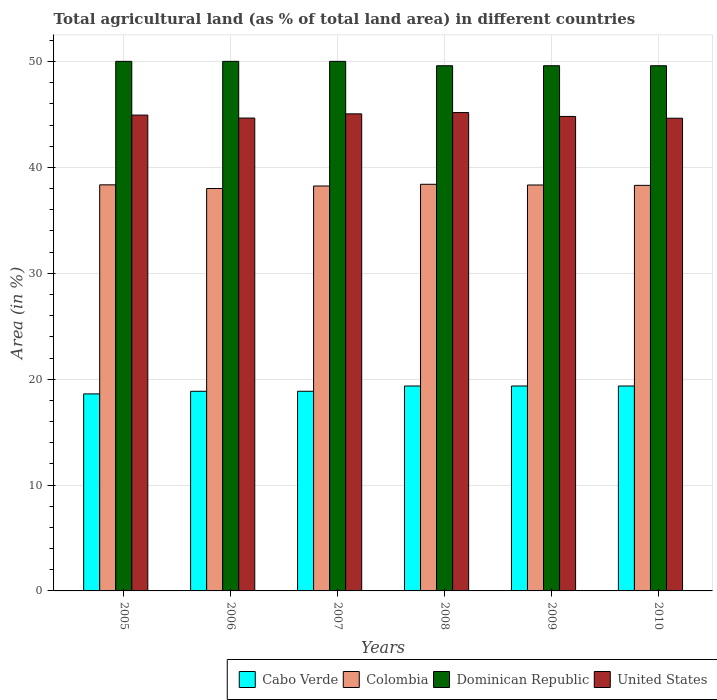Are the number of bars on each tick of the X-axis equal?
Give a very brief answer. Yes. How many bars are there on the 2nd tick from the left?
Offer a terse response. 4. What is the label of the 6th group of bars from the left?
Provide a short and direct response. 2010. In how many cases, is the number of bars for a given year not equal to the number of legend labels?
Offer a terse response. 0. What is the percentage of agricultural land in Colombia in 2007?
Your answer should be very brief. 38.25. Across all years, what is the maximum percentage of agricultural land in Dominican Republic?
Make the answer very short. 50.02. Across all years, what is the minimum percentage of agricultural land in Cabo Verde?
Keep it short and to the point. 18.61. In which year was the percentage of agricultural land in Dominican Republic minimum?
Provide a short and direct response. 2008. What is the total percentage of agricultural land in Colombia in the graph?
Ensure brevity in your answer.  229.67. What is the difference between the percentage of agricultural land in Cabo Verde in 2009 and the percentage of agricultural land in United States in 2006?
Your answer should be compact. -25.31. What is the average percentage of agricultural land in Cabo Verde per year?
Ensure brevity in your answer.  19.07. In the year 2006, what is the difference between the percentage of agricultural land in Colombia and percentage of agricultural land in Cabo Verde?
Your answer should be very brief. 19.15. What is the ratio of the percentage of agricultural land in United States in 2006 to that in 2010?
Ensure brevity in your answer.  1. Is the percentage of agricultural land in Dominican Republic in 2006 less than that in 2009?
Your response must be concise. No. What is the difference between the highest and the second highest percentage of agricultural land in Colombia?
Provide a short and direct response. 0.05. What is the difference between the highest and the lowest percentage of agricultural land in United States?
Offer a very short reply. 0.53. In how many years, is the percentage of agricultural land in Colombia greater than the average percentage of agricultural land in Colombia taken over all years?
Ensure brevity in your answer.  4. Is the sum of the percentage of agricultural land in Colombia in 2006 and 2007 greater than the maximum percentage of agricultural land in Dominican Republic across all years?
Offer a terse response. Yes. Is it the case that in every year, the sum of the percentage of agricultural land in Dominican Republic and percentage of agricultural land in United States is greater than the sum of percentage of agricultural land in Cabo Verde and percentage of agricultural land in Colombia?
Offer a very short reply. Yes. What does the 3rd bar from the left in 2005 represents?
Your answer should be compact. Dominican Republic. What does the 4th bar from the right in 2007 represents?
Your answer should be compact. Cabo Verde. How many bars are there?
Your answer should be compact. 24. What is the difference between two consecutive major ticks on the Y-axis?
Provide a succinct answer. 10. Are the values on the major ticks of Y-axis written in scientific E-notation?
Ensure brevity in your answer.  No. Does the graph contain grids?
Provide a succinct answer. Yes. Where does the legend appear in the graph?
Provide a short and direct response. Bottom right. How many legend labels are there?
Your answer should be compact. 4. What is the title of the graph?
Offer a terse response. Total agricultural land (as % of total land area) in different countries. What is the label or title of the X-axis?
Give a very brief answer. Years. What is the label or title of the Y-axis?
Offer a terse response. Area (in %). What is the Area (in %) in Cabo Verde in 2005?
Keep it short and to the point. 18.61. What is the Area (in %) in Colombia in 2005?
Provide a short and direct response. 38.36. What is the Area (in %) of Dominican Republic in 2005?
Offer a terse response. 50.02. What is the Area (in %) of United States in 2005?
Your answer should be very brief. 44.95. What is the Area (in %) in Cabo Verde in 2006?
Your response must be concise. 18.86. What is the Area (in %) in Colombia in 2006?
Offer a terse response. 38.01. What is the Area (in %) in Dominican Republic in 2006?
Offer a terse response. 50.02. What is the Area (in %) of United States in 2006?
Give a very brief answer. 44.66. What is the Area (in %) in Cabo Verde in 2007?
Your answer should be very brief. 18.86. What is the Area (in %) in Colombia in 2007?
Give a very brief answer. 38.25. What is the Area (in %) of Dominican Republic in 2007?
Your answer should be very brief. 50.02. What is the Area (in %) of United States in 2007?
Provide a short and direct response. 45.06. What is the Area (in %) of Cabo Verde in 2008?
Offer a terse response. 19.35. What is the Area (in %) of Colombia in 2008?
Your answer should be compact. 38.41. What is the Area (in %) in Dominican Republic in 2008?
Your answer should be compact. 49.61. What is the Area (in %) in United States in 2008?
Give a very brief answer. 45.18. What is the Area (in %) in Cabo Verde in 2009?
Provide a short and direct response. 19.35. What is the Area (in %) of Colombia in 2009?
Your answer should be compact. 38.34. What is the Area (in %) of Dominican Republic in 2009?
Your answer should be very brief. 49.61. What is the Area (in %) in United States in 2009?
Your response must be concise. 44.82. What is the Area (in %) in Cabo Verde in 2010?
Provide a succinct answer. 19.35. What is the Area (in %) of Colombia in 2010?
Provide a short and direct response. 38.31. What is the Area (in %) in Dominican Republic in 2010?
Make the answer very short. 49.61. What is the Area (in %) of United States in 2010?
Provide a succinct answer. 44.65. Across all years, what is the maximum Area (in %) in Cabo Verde?
Offer a terse response. 19.35. Across all years, what is the maximum Area (in %) in Colombia?
Keep it short and to the point. 38.41. Across all years, what is the maximum Area (in %) of Dominican Republic?
Your response must be concise. 50.02. Across all years, what is the maximum Area (in %) of United States?
Provide a succinct answer. 45.18. Across all years, what is the minimum Area (in %) in Cabo Verde?
Ensure brevity in your answer.  18.61. Across all years, what is the minimum Area (in %) in Colombia?
Your answer should be very brief. 38.01. Across all years, what is the minimum Area (in %) in Dominican Republic?
Provide a succinct answer. 49.61. Across all years, what is the minimum Area (in %) in United States?
Provide a short and direct response. 44.65. What is the total Area (in %) of Cabo Verde in the graph?
Your answer should be compact. 114.39. What is the total Area (in %) in Colombia in the graph?
Offer a terse response. 229.67. What is the total Area (in %) in Dominican Republic in the graph?
Provide a short and direct response. 298.88. What is the total Area (in %) of United States in the graph?
Offer a terse response. 269.32. What is the difference between the Area (in %) of Cabo Verde in 2005 and that in 2006?
Provide a succinct answer. -0.25. What is the difference between the Area (in %) in Colombia in 2005 and that in 2006?
Give a very brief answer. 0.35. What is the difference between the Area (in %) of Dominican Republic in 2005 and that in 2006?
Offer a very short reply. 0. What is the difference between the Area (in %) of United States in 2005 and that in 2006?
Make the answer very short. 0.28. What is the difference between the Area (in %) in Cabo Verde in 2005 and that in 2007?
Give a very brief answer. -0.25. What is the difference between the Area (in %) of Colombia in 2005 and that in 2007?
Make the answer very short. 0.11. What is the difference between the Area (in %) of Dominican Republic in 2005 and that in 2007?
Keep it short and to the point. 0. What is the difference between the Area (in %) of United States in 2005 and that in 2007?
Offer a very short reply. -0.12. What is the difference between the Area (in %) in Cabo Verde in 2005 and that in 2008?
Ensure brevity in your answer.  -0.74. What is the difference between the Area (in %) in Colombia in 2005 and that in 2008?
Your answer should be compact. -0.05. What is the difference between the Area (in %) of Dominican Republic in 2005 and that in 2008?
Your answer should be compact. 0.41. What is the difference between the Area (in %) in United States in 2005 and that in 2008?
Your answer should be very brief. -0.24. What is the difference between the Area (in %) in Cabo Verde in 2005 and that in 2009?
Give a very brief answer. -0.74. What is the difference between the Area (in %) in Colombia in 2005 and that in 2009?
Ensure brevity in your answer.  0.02. What is the difference between the Area (in %) in Dominican Republic in 2005 and that in 2009?
Provide a short and direct response. 0.41. What is the difference between the Area (in %) in United States in 2005 and that in 2009?
Give a very brief answer. 0.13. What is the difference between the Area (in %) of Cabo Verde in 2005 and that in 2010?
Your response must be concise. -0.74. What is the difference between the Area (in %) in Colombia in 2005 and that in 2010?
Give a very brief answer. 0.05. What is the difference between the Area (in %) in Dominican Republic in 2005 and that in 2010?
Provide a short and direct response. 0.41. What is the difference between the Area (in %) of United States in 2005 and that in 2010?
Your answer should be compact. 0.3. What is the difference between the Area (in %) in Cabo Verde in 2006 and that in 2007?
Your answer should be compact. 0. What is the difference between the Area (in %) in Colombia in 2006 and that in 2007?
Keep it short and to the point. -0.24. What is the difference between the Area (in %) of Dominican Republic in 2006 and that in 2007?
Ensure brevity in your answer.  0. What is the difference between the Area (in %) of United States in 2006 and that in 2007?
Offer a terse response. -0.4. What is the difference between the Area (in %) of Cabo Verde in 2006 and that in 2008?
Ensure brevity in your answer.  -0.5. What is the difference between the Area (in %) in Colombia in 2006 and that in 2008?
Offer a very short reply. -0.4. What is the difference between the Area (in %) in Dominican Republic in 2006 and that in 2008?
Your answer should be compact. 0.41. What is the difference between the Area (in %) in United States in 2006 and that in 2008?
Your response must be concise. -0.52. What is the difference between the Area (in %) of Cabo Verde in 2006 and that in 2009?
Keep it short and to the point. -0.5. What is the difference between the Area (in %) in Colombia in 2006 and that in 2009?
Your response must be concise. -0.33. What is the difference between the Area (in %) in Dominican Republic in 2006 and that in 2009?
Provide a succinct answer. 0.41. What is the difference between the Area (in %) in United States in 2006 and that in 2009?
Keep it short and to the point. -0.15. What is the difference between the Area (in %) in Cabo Verde in 2006 and that in 2010?
Your answer should be compact. -0.5. What is the difference between the Area (in %) in Colombia in 2006 and that in 2010?
Give a very brief answer. -0.3. What is the difference between the Area (in %) of Dominican Republic in 2006 and that in 2010?
Offer a terse response. 0.41. What is the difference between the Area (in %) in United States in 2006 and that in 2010?
Your answer should be compact. 0.02. What is the difference between the Area (in %) in Cabo Verde in 2007 and that in 2008?
Your answer should be very brief. -0.5. What is the difference between the Area (in %) of Colombia in 2007 and that in 2008?
Provide a succinct answer. -0.16. What is the difference between the Area (in %) in Dominican Republic in 2007 and that in 2008?
Offer a very short reply. 0.41. What is the difference between the Area (in %) in United States in 2007 and that in 2008?
Offer a very short reply. -0.12. What is the difference between the Area (in %) of Cabo Verde in 2007 and that in 2009?
Keep it short and to the point. -0.5. What is the difference between the Area (in %) in Colombia in 2007 and that in 2009?
Provide a succinct answer. -0.09. What is the difference between the Area (in %) of Dominican Republic in 2007 and that in 2009?
Provide a short and direct response. 0.41. What is the difference between the Area (in %) of United States in 2007 and that in 2009?
Your answer should be compact. 0.25. What is the difference between the Area (in %) in Cabo Verde in 2007 and that in 2010?
Your answer should be very brief. -0.5. What is the difference between the Area (in %) in Colombia in 2007 and that in 2010?
Offer a very short reply. -0.06. What is the difference between the Area (in %) of Dominican Republic in 2007 and that in 2010?
Ensure brevity in your answer.  0.41. What is the difference between the Area (in %) of United States in 2007 and that in 2010?
Make the answer very short. 0.41. What is the difference between the Area (in %) of Colombia in 2008 and that in 2009?
Your answer should be compact. 0.07. What is the difference between the Area (in %) in United States in 2008 and that in 2009?
Provide a succinct answer. 0.37. What is the difference between the Area (in %) in Dominican Republic in 2008 and that in 2010?
Give a very brief answer. 0. What is the difference between the Area (in %) in United States in 2008 and that in 2010?
Ensure brevity in your answer.  0.53. What is the difference between the Area (in %) in Cabo Verde in 2009 and that in 2010?
Your answer should be compact. 0. What is the difference between the Area (in %) of Dominican Republic in 2009 and that in 2010?
Your response must be concise. 0. What is the difference between the Area (in %) of United States in 2009 and that in 2010?
Ensure brevity in your answer.  0.17. What is the difference between the Area (in %) of Cabo Verde in 2005 and the Area (in %) of Colombia in 2006?
Ensure brevity in your answer.  -19.4. What is the difference between the Area (in %) of Cabo Verde in 2005 and the Area (in %) of Dominican Republic in 2006?
Your response must be concise. -31.41. What is the difference between the Area (in %) of Cabo Verde in 2005 and the Area (in %) of United States in 2006?
Keep it short and to the point. -26.05. What is the difference between the Area (in %) in Colombia in 2005 and the Area (in %) in Dominican Republic in 2006?
Offer a very short reply. -11.66. What is the difference between the Area (in %) of Colombia in 2005 and the Area (in %) of United States in 2006?
Your response must be concise. -6.31. What is the difference between the Area (in %) in Dominican Republic in 2005 and the Area (in %) in United States in 2006?
Give a very brief answer. 5.36. What is the difference between the Area (in %) of Cabo Verde in 2005 and the Area (in %) of Colombia in 2007?
Make the answer very short. -19.64. What is the difference between the Area (in %) in Cabo Verde in 2005 and the Area (in %) in Dominican Republic in 2007?
Provide a succinct answer. -31.41. What is the difference between the Area (in %) of Cabo Verde in 2005 and the Area (in %) of United States in 2007?
Make the answer very short. -26.45. What is the difference between the Area (in %) in Colombia in 2005 and the Area (in %) in Dominican Republic in 2007?
Ensure brevity in your answer.  -11.66. What is the difference between the Area (in %) in Colombia in 2005 and the Area (in %) in United States in 2007?
Offer a terse response. -6.71. What is the difference between the Area (in %) of Dominican Republic in 2005 and the Area (in %) of United States in 2007?
Keep it short and to the point. 4.96. What is the difference between the Area (in %) in Cabo Verde in 2005 and the Area (in %) in Colombia in 2008?
Provide a succinct answer. -19.8. What is the difference between the Area (in %) of Cabo Verde in 2005 and the Area (in %) of Dominican Republic in 2008?
Your answer should be compact. -31. What is the difference between the Area (in %) of Cabo Verde in 2005 and the Area (in %) of United States in 2008?
Give a very brief answer. -26.57. What is the difference between the Area (in %) of Colombia in 2005 and the Area (in %) of Dominican Republic in 2008?
Give a very brief answer. -11.25. What is the difference between the Area (in %) in Colombia in 2005 and the Area (in %) in United States in 2008?
Provide a succinct answer. -6.83. What is the difference between the Area (in %) in Dominican Republic in 2005 and the Area (in %) in United States in 2008?
Make the answer very short. 4.84. What is the difference between the Area (in %) of Cabo Verde in 2005 and the Area (in %) of Colombia in 2009?
Provide a succinct answer. -19.73. What is the difference between the Area (in %) in Cabo Verde in 2005 and the Area (in %) in Dominican Republic in 2009?
Ensure brevity in your answer.  -31. What is the difference between the Area (in %) in Cabo Verde in 2005 and the Area (in %) in United States in 2009?
Keep it short and to the point. -26.21. What is the difference between the Area (in %) of Colombia in 2005 and the Area (in %) of Dominican Republic in 2009?
Offer a very short reply. -11.25. What is the difference between the Area (in %) in Colombia in 2005 and the Area (in %) in United States in 2009?
Ensure brevity in your answer.  -6.46. What is the difference between the Area (in %) in Dominican Republic in 2005 and the Area (in %) in United States in 2009?
Ensure brevity in your answer.  5.2. What is the difference between the Area (in %) in Cabo Verde in 2005 and the Area (in %) in Colombia in 2010?
Offer a very short reply. -19.7. What is the difference between the Area (in %) of Cabo Verde in 2005 and the Area (in %) of Dominican Republic in 2010?
Ensure brevity in your answer.  -31. What is the difference between the Area (in %) of Cabo Verde in 2005 and the Area (in %) of United States in 2010?
Provide a succinct answer. -26.04. What is the difference between the Area (in %) in Colombia in 2005 and the Area (in %) in Dominican Republic in 2010?
Provide a short and direct response. -11.25. What is the difference between the Area (in %) in Colombia in 2005 and the Area (in %) in United States in 2010?
Provide a succinct answer. -6.29. What is the difference between the Area (in %) of Dominican Republic in 2005 and the Area (in %) of United States in 2010?
Provide a short and direct response. 5.37. What is the difference between the Area (in %) of Cabo Verde in 2006 and the Area (in %) of Colombia in 2007?
Ensure brevity in your answer.  -19.39. What is the difference between the Area (in %) in Cabo Verde in 2006 and the Area (in %) in Dominican Republic in 2007?
Offer a terse response. -31.16. What is the difference between the Area (in %) of Cabo Verde in 2006 and the Area (in %) of United States in 2007?
Offer a very short reply. -26.2. What is the difference between the Area (in %) in Colombia in 2006 and the Area (in %) in Dominican Republic in 2007?
Your answer should be very brief. -12.01. What is the difference between the Area (in %) of Colombia in 2006 and the Area (in %) of United States in 2007?
Provide a short and direct response. -7.05. What is the difference between the Area (in %) of Dominican Republic in 2006 and the Area (in %) of United States in 2007?
Your answer should be compact. 4.96. What is the difference between the Area (in %) in Cabo Verde in 2006 and the Area (in %) in Colombia in 2008?
Give a very brief answer. -19.55. What is the difference between the Area (in %) of Cabo Verde in 2006 and the Area (in %) of Dominican Republic in 2008?
Make the answer very short. -30.75. What is the difference between the Area (in %) of Cabo Verde in 2006 and the Area (in %) of United States in 2008?
Give a very brief answer. -26.32. What is the difference between the Area (in %) of Colombia in 2006 and the Area (in %) of Dominican Republic in 2008?
Ensure brevity in your answer.  -11.6. What is the difference between the Area (in %) of Colombia in 2006 and the Area (in %) of United States in 2008?
Offer a terse response. -7.17. What is the difference between the Area (in %) in Dominican Republic in 2006 and the Area (in %) in United States in 2008?
Your response must be concise. 4.84. What is the difference between the Area (in %) in Cabo Verde in 2006 and the Area (in %) in Colombia in 2009?
Your answer should be compact. -19.48. What is the difference between the Area (in %) of Cabo Verde in 2006 and the Area (in %) of Dominican Republic in 2009?
Provide a succinct answer. -30.75. What is the difference between the Area (in %) of Cabo Verde in 2006 and the Area (in %) of United States in 2009?
Your answer should be very brief. -25.96. What is the difference between the Area (in %) of Colombia in 2006 and the Area (in %) of Dominican Republic in 2009?
Ensure brevity in your answer.  -11.6. What is the difference between the Area (in %) of Colombia in 2006 and the Area (in %) of United States in 2009?
Provide a short and direct response. -6.81. What is the difference between the Area (in %) in Dominican Republic in 2006 and the Area (in %) in United States in 2009?
Provide a short and direct response. 5.2. What is the difference between the Area (in %) of Cabo Verde in 2006 and the Area (in %) of Colombia in 2010?
Make the answer very short. -19.45. What is the difference between the Area (in %) in Cabo Verde in 2006 and the Area (in %) in Dominican Republic in 2010?
Your answer should be very brief. -30.75. What is the difference between the Area (in %) in Cabo Verde in 2006 and the Area (in %) in United States in 2010?
Give a very brief answer. -25.79. What is the difference between the Area (in %) in Colombia in 2006 and the Area (in %) in Dominican Republic in 2010?
Your answer should be compact. -11.6. What is the difference between the Area (in %) of Colombia in 2006 and the Area (in %) of United States in 2010?
Your answer should be very brief. -6.64. What is the difference between the Area (in %) of Dominican Republic in 2006 and the Area (in %) of United States in 2010?
Your answer should be compact. 5.37. What is the difference between the Area (in %) of Cabo Verde in 2007 and the Area (in %) of Colombia in 2008?
Ensure brevity in your answer.  -19.55. What is the difference between the Area (in %) of Cabo Verde in 2007 and the Area (in %) of Dominican Republic in 2008?
Offer a terse response. -30.75. What is the difference between the Area (in %) of Cabo Verde in 2007 and the Area (in %) of United States in 2008?
Your answer should be compact. -26.32. What is the difference between the Area (in %) of Colombia in 2007 and the Area (in %) of Dominican Republic in 2008?
Your answer should be very brief. -11.36. What is the difference between the Area (in %) of Colombia in 2007 and the Area (in %) of United States in 2008?
Keep it short and to the point. -6.94. What is the difference between the Area (in %) in Dominican Republic in 2007 and the Area (in %) in United States in 2008?
Your answer should be very brief. 4.84. What is the difference between the Area (in %) of Cabo Verde in 2007 and the Area (in %) of Colombia in 2009?
Offer a terse response. -19.48. What is the difference between the Area (in %) in Cabo Verde in 2007 and the Area (in %) in Dominican Republic in 2009?
Keep it short and to the point. -30.75. What is the difference between the Area (in %) in Cabo Verde in 2007 and the Area (in %) in United States in 2009?
Make the answer very short. -25.96. What is the difference between the Area (in %) of Colombia in 2007 and the Area (in %) of Dominican Republic in 2009?
Your answer should be very brief. -11.36. What is the difference between the Area (in %) of Colombia in 2007 and the Area (in %) of United States in 2009?
Offer a terse response. -6.57. What is the difference between the Area (in %) of Dominican Republic in 2007 and the Area (in %) of United States in 2009?
Offer a very short reply. 5.2. What is the difference between the Area (in %) in Cabo Verde in 2007 and the Area (in %) in Colombia in 2010?
Your answer should be very brief. -19.45. What is the difference between the Area (in %) of Cabo Verde in 2007 and the Area (in %) of Dominican Republic in 2010?
Ensure brevity in your answer.  -30.75. What is the difference between the Area (in %) of Cabo Verde in 2007 and the Area (in %) of United States in 2010?
Keep it short and to the point. -25.79. What is the difference between the Area (in %) in Colombia in 2007 and the Area (in %) in Dominican Republic in 2010?
Ensure brevity in your answer.  -11.36. What is the difference between the Area (in %) of Colombia in 2007 and the Area (in %) of United States in 2010?
Ensure brevity in your answer.  -6.4. What is the difference between the Area (in %) in Dominican Republic in 2007 and the Area (in %) in United States in 2010?
Ensure brevity in your answer.  5.37. What is the difference between the Area (in %) in Cabo Verde in 2008 and the Area (in %) in Colombia in 2009?
Your answer should be very brief. -18.99. What is the difference between the Area (in %) in Cabo Verde in 2008 and the Area (in %) in Dominican Republic in 2009?
Make the answer very short. -30.25. What is the difference between the Area (in %) in Cabo Verde in 2008 and the Area (in %) in United States in 2009?
Your answer should be very brief. -25.46. What is the difference between the Area (in %) of Colombia in 2008 and the Area (in %) of Dominican Republic in 2009?
Your response must be concise. -11.2. What is the difference between the Area (in %) of Colombia in 2008 and the Area (in %) of United States in 2009?
Your answer should be very brief. -6.41. What is the difference between the Area (in %) of Dominican Republic in 2008 and the Area (in %) of United States in 2009?
Provide a short and direct response. 4.79. What is the difference between the Area (in %) of Cabo Verde in 2008 and the Area (in %) of Colombia in 2010?
Make the answer very short. -18.95. What is the difference between the Area (in %) in Cabo Verde in 2008 and the Area (in %) in Dominican Republic in 2010?
Your answer should be compact. -30.25. What is the difference between the Area (in %) in Cabo Verde in 2008 and the Area (in %) in United States in 2010?
Offer a terse response. -25.29. What is the difference between the Area (in %) of Colombia in 2008 and the Area (in %) of Dominican Republic in 2010?
Ensure brevity in your answer.  -11.2. What is the difference between the Area (in %) of Colombia in 2008 and the Area (in %) of United States in 2010?
Provide a succinct answer. -6.24. What is the difference between the Area (in %) in Dominican Republic in 2008 and the Area (in %) in United States in 2010?
Your answer should be very brief. 4.96. What is the difference between the Area (in %) of Cabo Verde in 2009 and the Area (in %) of Colombia in 2010?
Provide a succinct answer. -18.95. What is the difference between the Area (in %) of Cabo Verde in 2009 and the Area (in %) of Dominican Republic in 2010?
Keep it short and to the point. -30.25. What is the difference between the Area (in %) of Cabo Verde in 2009 and the Area (in %) of United States in 2010?
Your answer should be compact. -25.29. What is the difference between the Area (in %) of Colombia in 2009 and the Area (in %) of Dominican Republic in 2010?
Your answer should be very brief. -11.27. What is the difference between the Area (in %) of Colombia in 2009 and the Area (in %) of United States in 2010?
Your response must be concise. -6.31. What is the difference between the Area (in %) of Dominican Republic in 2009 and the Area (in %) of United States in 2010?
Offer a terse response. 4.96. What is the average Area (in %) in Cabo Verde per year?
Provide a short and direct response. 19.07. What is the average Area (in %) in Colombia per year?
Your answer should be very brief. 38.28. What is the average Area (in %) in Dominican Republic per year?
Provide a succinct answer. 49.81. What is the average Area (in %) in United States per year?
Your answer should be very brief. 44.89. In the year 2005, what is the difference between the Area (in %) in Cabo Verde and Area (in %) in Colombia?
Your answer should be compact. -19.75. In the year 2005, what is the difference between the Area (in %) of Cabo Verde and Area (in %) of Dominican Republic?
Give a very brief answer. -31.41. In the year 2005, what is the difference between the Area (in %) in Cabo Verde and Area (in %) in United States?
Your answer should be compact. -26.33. In the year 2005, what is the difference between the Area (in %) in Colombia and Area (in %) in Dominican Republic?
Ensure brevity in your answer.  -11.66. In the year 2005, what is the difference between the Area (in %) in Colombia and Area (in %) in United States?
Make the answer very short. -6.59. In the year 2005, what is the difference between the Area (in %) in Dominican Republic and Area (in %) in United States?
Ensure brevity in your answer.  5.08. In the year 2006, what is the difference between the Area (in %) in Cabo Verde and Area (in %) in Colombia?
Offer a very short reply. -19.15. In the year 2006, what is the difference between the Area (in %) of Cabo Verde and Area (in %) of Dominican Republic?
Offer a terse response. -31.16. In the year 2006, what is the difference between the Area (in %) of Cabo Verde and Area (in %) of United States?
Keep it short and to the point. -25.81. In the year 2006, what is the difference between the Area (in %) of Colombia and Area (in %) of Dominican Republic?
Your answer should be very brief. -12.01. In the year 2006, what is the difference between the Area (in %) in Colombia and Area (in %) in United States?
Provide a short and direct response. -6.65. In the year 2006, what is the difference between the Area (in %) of Dominican Republic and Area (in %) of United States?
Your answer should be compact. 5.36. In the year 2007, what is the difference between the Area (in %) in Cabo Verde and Area (in %) in Colombia?
Your answer should be compact. -19.39. In the year 2007, what is the difference between the Area (in %) of Cabo Verde and Area (in %) of Dominican Republic?
Provide a short and direct response. -31.16. In the year 2007, what is the difference between the Area (in %) in Cabo Verde and Area (in %) in United States?
Provide a succinct answer. -26.2. In the year 2007, what is the difference between the Area (in %) in Colombia and Area (in %) in Dominican Republic?
Provide a short and direct response. -11.77. In the year 2007, what is the difference between the Area (in %) of Colombia and Area (in %) of United States?
Offer a very short reply. -6.81. In the year 2007, what is the difference between the Area (in %) in Dominican Republic and Area (in %) in United States?
Your response must be concise. 4.96. In the year 2008, what is the difference between the Area (in %) in Cabo Verde and Area (in %) in Colombia?
Offer a very short reply. -19.05. In the year 2008, what is the difference between the Area (in %) of Cabo Verde and Area (in %) of Dominican Republic?
Keep it short and to the point. -30.25. In the year 2008, what is the difference between the Area (in %) of Cabo Verde and Area (in %) of United States?
Your answer should be compact. -25.83. In the year 2008, what is the difference between the Area (in %) of Colombia and Area (in %) of Dominican Republic?
Keep it short and to the point. -11.2. In the year 2008, what is the difference between the Area (in %) of Colombia and Area (in %) of United States?
Provide a succinct answer. -6.78. In the year 2008, what is the difference between the Area (in %) of Dominican Republic and Area (in %) of United States?
Offer a very short reply. 4.42. In the year 2009, what is the difference between the Area (in %) of Cabo Verde and Area (in %) of Colombia?
Keep it short and to the point. -18.99. In the year 2009, what is the difference between the Area (in %) of Cabo Verde and Area (in %) of Dominican Republic?
Your response must be concise. -30.25. In the year 2009, what is the difference between the Area (in %) of Cabo Verde and Area (in %) of United States?
Keep it short and to the point. -25.46. In the year 2009, what is the difference between the Area (in %) of Colombia and Area (in %) of Dominican Republic?
Your answer should be very brief. -11.27. In the year 2009, what is the difference between the Area (in %) in Colombia and Area (in %) in United States?
Provide a succinct answer. -6.48. In the year 2009, what is the difference between the Area (in %) of Dominican Republic and Area (in %) of United States?
Offer a terse response. 4.79. In the year 2010, what is the difference between the Area (in %) in Cabo Verde and Area (in %) in Colombia?
Your answer should be compact. -18.95. In the year 2010, what is the difference between the Area (in %) of Cabo Verde and Area (in %) of Dominican Republic?
Keep it short and to the point. -30.25. In the year 2010, what is the difference between the Area (in %) in Cabo Verde and Area (in %) in United States?
Your answer should be very brief. -25.29. In the year 2010, what is the difference between the Area (in %) of Colombia and Area (in %) of Dominican Republic?
Give a very brief answer. -11.3. In the year 2010, what is the difference between the Area (in %) in Colombia and Area (in %) in United States?
Make the answer very short. -6.34. In the year 2010, what is the difference between the Area (in %) in Dominican Republic and Area (in %) in United States?
Give a very brief answer. 4.96. What is the ratio of the Area (in %) in Cabo Verde in 2005 to that in 2006?
Your answer should be compact. 0.99. What is the ratio of the Area (in %) of Colombia in 2005 to that in 2006?
Your response must be concise. 1.01. What is the ratio of the Area (in %) in Dominican Republic in 2005 to that in 2006?
Offer a terse response. 1. What is the ratio of the Area (in %) of United States in 2005 to that in 2006?
Offer a very short reply. 1.01. What is the ratio of the Area (in %) of Cabo Verde in 2005 to that in 2007?
Keep it short and to the point. 0.99. What is the ratio of the Area (in %) in Cabo Verde in 2005 to that in 2008?
Keep it short and to the point. 0.96. What is the ratio of the Area (in %) of Dominican Republic in 2005 to that in 2008?
Make the answer very short. 1.01. What is the ratio of the Area (in %) in Cabo Verde in 2005 to that in 2009?
Offer a terse response. 0.96. What is the ratio of the Area (in %) in Colombia in 2005 to that in 2009?
Keep it short and to the point. 1. What is the ratio of the Area (in %) in Dominican Republic in 2005 to that in 2009?
Provide a succinct answer. 1.01. What is the ratio of the Area (in %) of United States in 2005 to that in 2009?
Offer a very short reply. 1. What is the ratio of the Area (in %) in Cabo Verde in 2005 to that in 2010?
Provide a short and direct response. 0.96. What is the ratio of the Area (in %) in Dominican Republic in 2005 to that in 2010?
Offer a terse response. 1.01. What is the ratio of the Area (in %) in United States in 2005 to that in 2010?
Give a very brief answer. 1.01. What is the ratio of the Area (in %) in Cabo Verde in 2006 to that in 2007?
Ensure brevity in your answer.  1. What is the ratio of the Area (in %) of Colombia in 2006 to that in 2007?
Your response must be concise. 0.99. What is the ratio of the Area (in %) of United States in 2006 to that in 2007?
Offer a terse response. 0.99. What is the ratio of the Area (in %) of Cabo Verde in 2006 to that in 2008?
Make the answer very short. 0.97. What is the ratio of the Area (in %) of Dominican Republic in 2006 to that in 2008?
Provide a succinct answer. 1.01. What is the ratio of the Area (in %) in Cabo Verde in 2006 to that in 2009?
Keep it short and to the point. 0.97. What is the ratio of the Area (in %) in Colombia in 2006 to that in 2009?
Keep it short and to the point. 0.99. What is the ratio of the Area (in %) in Dominican Republic in 2006 to that in 2009?
Offer a very short reply. 1.01. What is the ratio of the Area (in %) in Cabo Verde in 2006 to that in 2010?
Offer a terse response. 0.97. What is the ratio of the Area (in %) in Colombia in 2006 to that in 2010?
Your answer should be compact. 0.99. What is the ratio of the Area (in %) in Dominican Republic in 2006 to that in 2010?
Your answer should be compact. 1.01. What is the ratio of the Area (in %) of United States in 2006 to that in 2010?
Provide a succinct answer. 1. What is the ratio of the Area (in %) of Cabo Verde in 2007 to that in 2008?
Offer a very short reply. 0.97. What is the ratio of the Area (in %) of Dominican Republic in 2007 to that in 2008?
Keep it short and to the point. 1.01. What is the ratio of the Area (in %) in Cabo Verde in 2007 to that in 2009?
Your response must be concise. 0.97. What is the ratio of the Area (in %) in Colombia in 2007 to that in 2009?
Give a very brief answer. 1. What is the ratio of the Area (in %) in Dominican Republic in 2007 to that in 2009?
Give a very brief answer. 1.01. What is the ratio of the Area (in %) in Cabo Verde in 2007 to that in 2010?
Your answer should be very brief. 0.97. What is the ratio of the Area (in %) in Dominican Republic in 2007 to that in 2010?
Give a very brief answer. 1.01. What is the ratio of the Area (in %) in United States in 2007 to that in 2010?
Your answer should be compact. 1.01. What is the ratio of the Area (in %) of Colombia in 2008 to that in 2009?
Offer a very short reply. 1. What is the ratio of the Area (in %) of United States in 2008 to that in 2009?
Keep it short and to the point. 1.01. What is the ratio of the Area (in %) in Colombia in 2008 to that in 2010?
Provide a succinct answer. 1. What is the ratio of the Area (in %) of Cabo Verde in 2009 to that in 2010?
Make the answer very short. 1. What is the ratio of the Area (in %) in United States in 2009 to that in 2010?
Offer a terse response. 1. What is the difference between the highest and the second highest Area (in %) in Cabo Verde?
Offer a very short reply. 0. What is the difference between the highest and the second highest Area (in %) of Colombia?
Ensure brevity in your answer.  0.05. What is the difference between the highest and the second highest Area (in %) of United States?
Your response must be concise. 0.12. What is the difference between the highest and the lowest Area (in %) of Cabo Verde?
Provide a short and direct response. 0.74. What is the difference between the highest and the lowest Area (in %) of Colombia?
Provide a succinct answer. 0.4. What is the difference between the highest and the lowest Area (in %) of Dominican Republic?
Give a very brief answer. 0.41. What is the difference between the highest and the lowest Area (in %) of United States?
Keep it short and to the point. 0.53. 